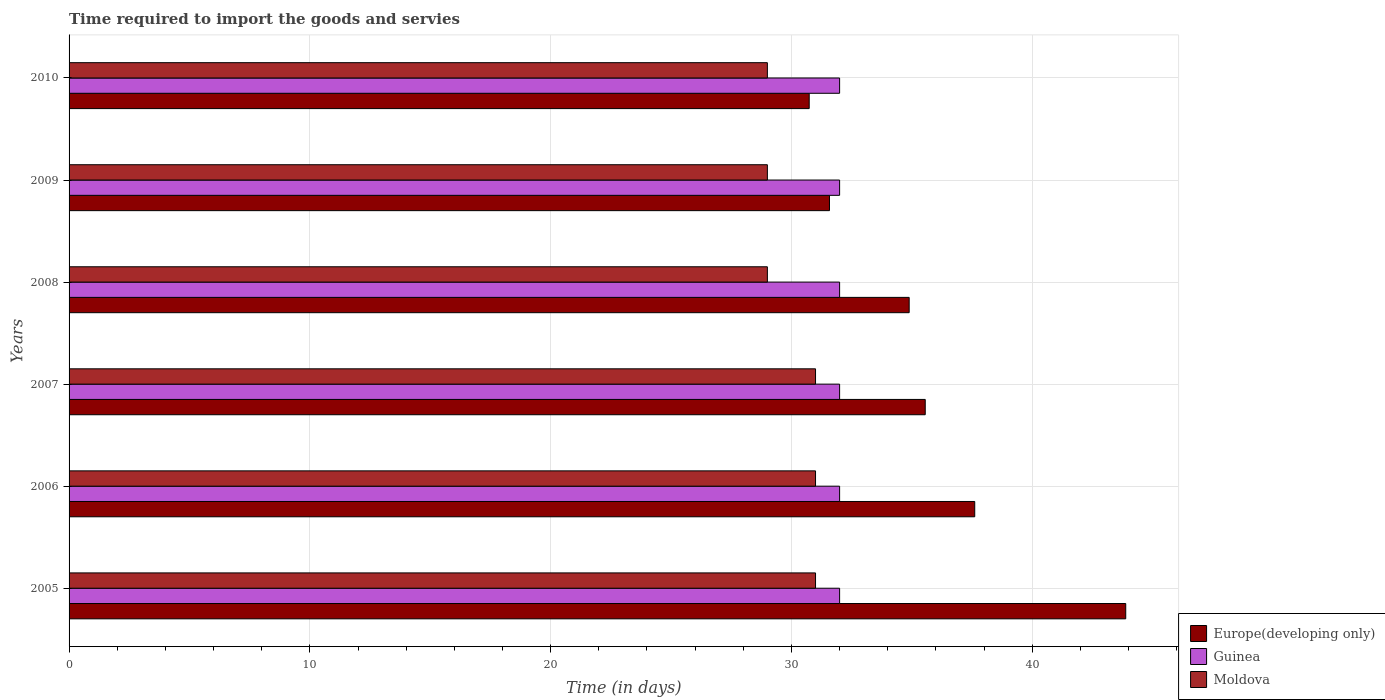How many groups of bars are there?
Make the answer very short. 6. Are the number of bars on each tick of the Y-axis equal?
Ensure brevity in your answer.  Yes. How many bars are there on the 2nd tick from the top?
Provide a short and direct response. 3. How many bars are there on the 3rd tick from the bottom?
Your answer should be very brief. 3. In how many cases, is the number of bars for a given year not equal to the number of legend labels?
Your answer should be compact. 0. What is the number of days required to import the goods and services in Europe(developing only) in 2006?
Offer a terse response. 37.61. Across all years, what is the maximum number of days required to import the goods and services in Guinea?
Keep it short and to the point. 32. Across all years, what is the minimum number of days required to import the goods and services in Europe(developing only)?
Make the answer very short. 30.74. In which year was the number of days required to import the goods and services in Europe(developing only) maximum?
Your answer should be very brief. 2005. In which year was the number of days required to import the goods and services in Europe(developing only) minimum?
Your response must be concise. 2010. What is the total number of days required to import the goods and services in Europe(developing only) in the graph?
Your answer should be very brief. 214.25. What is the difference between the number of days required to import the goods and services in Europe(developing only) in 2005 and that in 2007?
Your response must be concise. 8.33. What is the difference between the number of days required to import the goods and services in Europe(developing only) in 2010 and the number of days required to import the goods and services in Moldova in 2008?
Ensure brevity in your answer.  1.74. In the year 2008, what is the difference between the number of days required to import the goods and services in Europe(developing only) and number of days required to import the goods and services in Moldova?
Make the answer very short. 5.89. What is the ratio of the number of days required to import the goods and services in Europe(developing only) in 2005 to that in 2006?
Provide a succinct answer. 1.17. Is the number of days required to import the goods and services in Guinea in 2007 less than that in 2010?
Your response must be concise. No. What is the difference between the highest and the second highest number of days required to import the goods and services in Guinea?
Make the answer very short. 0. What is the difference between the highest and the lowest number of days required to import the goods and services in Moldova?
Offer a very short reply. 2. What does the 2nd bar from the top in 2009 represents?
Keep it short and to the point. Guinea. What does the 1st bar from the bottom in 2009 represents?
Provide a succinct answer. Europe(developing only). Is it the case that in every year, the sum of the number of days required to import the goods and services in Europe(developing only) and number of days required to import the goods and services in Moldova is greater than the number of days required to import the goods and services in Guinea?
Your response must be concise. Yes. How many years are there in the graph?
Provide a short and direct response. 6. What is the difference between two consecutive major ticks on the X-axis?
Keep it short and to the point. 10. Are the values on the major ticks of X-axis written in scientific E-notation?
Provide a short and direct response. No. Does the graph contain grids?
Provide a short and direct response. Yes. How many legend labels are there?
Your answer should be compact. 3. How are the legend labels stacked?
Provide a succinct answer. Vertical. What is the title of the graph?
Ensure brevity in your answer.  Time required to import the goods and servies. What is the label or title of the X-axis?
Provide a short and direct response. Time (in days). What is the Time (in days) in Europe(developing only) in 2005?
Provide a succinct answer. 43.88. What is the Time (in days) of Moldova in 2005?
Keep it short and to the point. 31. What is the Time (in days) in Europe(developing only) in 2006?
Ensure brevity in your answer.  37.61. What is the Time (in days) in Guinea in 2006?
Your answer should be compact. 32. What is the Time (in days) of Moldova in 2006?
Your answer should be very brief. 31. What is the Time (in days) of Europe(developing only) in 2007?
Offer a very short reply. 35.56. What is the Time (in days) in Guinea in 2007?
Your answer should be very brief. 32. What is the Time (in days) of Moldova in 2007?
Your response must be concise. 31. What is the Time (in days) of Europe(developing only) in 2008?
Your response must be concise. 34.89. What is the Time (in days) in Guinea in 2008?
Offer a very short reply. 32. What is the Time (in days) of Moldova in 2008?
Give a very brief answer. 29. What is the Time (in days) in Europe(developing only) in 2009?
Provide a short and direct response. 31.58. What is the Time (in days) in Guinea in 2009?
Ensure brevity in your answer.  32. What is the Time (in days) in Moldova in 2009?
Provide a short and direct response. 29. What is the Time (in days) in Europe(developing only) in 2010?
Make the answer very short. 30.74. Across all years, what is the maximum Time (in days) of Europe(developing only)?
Keep it short and to the point. 43.88. Across all years, what is the maximum Time (in days) of Guinea?
Offer a very short reply. 32. Across all years, what is the maximum Time (in days) in Moldova?
Provide a succinct answer. 31. Across all years, what is the minimum Time (in days) in Europe(developing only)?
Your response must be concise. 30.74. Across all years, what is the minimum Time (in days) of Guinea?
Your answer should be compact. 32. Across all years, what is the minimum Time (in days) in Moldova?
Provide a succinct answer. 29. What is the total Time (in days) in Europe(developing only) in the graph?
Make the answer very short. 214.25. What is the total Time (in days) of Guinea in the graph?
Your answer should be compact. 192. What is the total Time (in days) in Moldova in the graph?
Your response must be concise. 180. What is the difference between the Time (in days) of Europe(developing only) in 2005 and that in 2006?
Keep it short and to the point. 6.27. What is the difference between the Time (in days) in Europe(developing only) in 2005 and that in 2007?
Keep it short and to the point. 8.33. What is the difference between the Time (in days) of Guinea in 2005 and that in 2007?
Give a very brief answer. 0. What is the difference between the Time (in days) of Europe(developing only) in 2005 and that in 2008?
Give a very brief answer. 8.99. What is the difference between the Time (in days) in Guinea in 2005 and that in 2008?
Offer a terse response. 0. What is the difference between the Time (in days) in Europe(developing only) in 2005 and that in 2009?
Your response must be concise. 12.3. What is the difference between the Time (in days) in Guinea in 2005 and that in 2009?
Offer a very short reply. 0. What is the difference between the Time (in days) in Moldova in 2005 and that in 2009?
Provide a succinct answer. 2. What is the difference between the Time (in days) of Europe(developing only) in 2005 and that in 2010?
Make the answer very short. 13.15. What is the difference between the Time (in days) in Europe(developing only) in 2006 and that in 2007?
Offer a very short reply. 2.06. What is the difference between the Time (in days) of Guinea in 2006 and that in 2007?
Make the answer very short. 0. What is the difference between the Time (in days) of Moldova in 2006 and that in 2007?
Offer a very short reply. 0. What is the difference between the Time (in days) of Europe(developing only) in 2006 and that in 2008?
Your answer should be very brief. 2.72. What is the difference between the Time (in days) of Guinea in 2006 and that in 2008?
Offer a terse response. 0. What is the difference between the Time (in days) of Moldova in 2006 and that in 2008?
Provide a short and direct response. 2. What is the difference between the Time (in days) of Europe(developing only) in 2006 and that in 2009?
Your answer should be very brief. 6.03. What is the difference between the Time (in days) of Guinea in 2006 and that in 2009?
Your response must be concise. 0. What is the difference between the Time (in days) in Europe(developing only) in 2006 and that in 2010?
Offer a terse response. 6.87. What is the difference between the Time (in days) in Moldova in 2007 and that in 2008?
Offer a very short reply. 2. What is the difference between the Time (in days) in Europe(developing only) in 2007 and that in 2009?
Offer a very short reply. 3.98. What is the difference between the Time (in days) in Europe(developing only) in 2007 and that in 2010?
Make the answer very short. 4.82. What is the difference between the Time (in days) of Guinea in 2007 and that in 2010?
Provide a short and direct response. 0. What is the difference between the Time (in days) in Moldova in 2007 and that in 2010?
Your response must be concise. 2. What is the difference between the Time (in days) in Europe(developing only) in 2008 and that in 2009?
Your response must be concise. 3.31. What is the difference between the Time (in days) of Guinea in 2008 and that in 2009?
Give a very brief answer. 0. What is the difference between the Time (in days) of Moldova in 2008 and that in 2009?
Make the answer very short. 0. What is the difference between the Time (in days) in Europe(developing only) in 2008 and that in 2010?
Offer a terse response. 4.15. What is the difference between the Time (in days) in Guinea in 2008 and that in 2010?
Offer a terse response. 0. What is the difference between the Time (in days) in Moldova in 2008 and that in 2010?
Keep it short and to the point. 0. What is the difference between the Time (in days) in Europe(developing only) in 2009 and that in 2010?
Ensure brevity in your answer.  0.84. What is the difference between the Time (in days) in Guinea in 2009 and that in 2010?
Ensure brevity in your answer.  0. What is the difference between the Time (in days) of Europe(developing only) in 2005 and the Time (in days) of Guinea in 2006?
Ensure brevity in your answer.  11.88. What is the difference between the Time (in days) of Europe(developing only) in 2005 and the Time (in days) of Moldova in 2006?
Your response must be concise. 12.88. What is the difference between the Time (in days) of Europe(developing only) in 2005 and the Time (in days) of Guinea in 2007?
Offer a very short reply. 11.88. What is the difference between the Time (in days) in Europe(developing only) in 2005 and the Time (in days) in Moldova in 2007?
Your answer should be compact. 12.88. What is the difference between the Time (in days) of Europe(developing only) in 2005 and the Time (in days) of Guinea in 2008?
Provide a succinct answer. 11.88. What is the difference between the Time (in days) of Europe(developing only) in 2005 and the Time (in days) of Moldova in 2008?
Give a very brief answer. 14.88. What is the difference between the Time (in days) of Guinea in 2005 and the Time (in days) of Moldova in 2008?
Your answer should be very brief. 3. What is the difference between the Time (in days) of Europe(developing only) in 2005 and the Time (in days) of Guinea in 2009?
Your response must be concise. 11.88. What is the difference between the Time (in days) in Europe(developing only) in 2005 and the Time (in days) in Moldova in 2009?
Provide a short and direct response. 14.88. What is the difference between the Time (in days) of Guinea in 2005 and the Time (in days) of Moldova in 2009?
Offer a very short reply. 3. What is the difference between the Time (in days) of Europe(developing only) in 2005 and the Time (in days) of Guinea in 2010?
Ensure brevity in your answer.  11.88. What is the difference between the Time (in days) of Europe(developing only) in 2005 and the Time (in days) of Moldova in 2010?
Make the answer very short. 14.88. What is the difference between the Time (in days) in Guinea in 2005 and the Time (in days) in Moldova in 2010?
Your response must be concise. 3. What is the difference between the Time (in days) in Europe(developing only) in 2006 and the Time (in days) in Guinea in 2007?
Your answer should be compact. 5.61. What is the difference between the Time (in days) of Europe(developing only) in 2006 and the Time (in days) of Moldova in 2007?
Your answer should be very brief. 6.61. What is the difference between the Time (in days) in Europe(developing only) in 2006 and the Time (in days) in Guinea in 2008?
Offer a very short reply. 5.61. What is the difference between the Time (in days) of Europe(developing only) in 2006 and the Time (in days) of Moldova in 2008?
Your response must be concise. 8.61. What is the difference between the Time (in days) of Guinea in 2006 and the Time (in days) of Moldova in 2008?
Your response must be concise. 3. What is the difference between the Time (in days) in Europe(developing only) in 2006 and the Time (in days) in Guinea in 2009?
Offer a terse response. 5.61. What is the difference between the Time (in days) of Europe(developing only) in 2006 and the Time (in days) of Moldova in 2009?
Keep it short and to the point. 8.61. What is the difference between the Time (in days) in Guinea in 2006 and the Time (in days) in Moldova in 2009?
Make the answer very short. 3. What is the difference between the Time (in days) of Europe(developing only) in 2006 and the Time (in days) of Guinea in 2010?
Make the answer very short. 5.61. What is the difference between the Time (in days) in Europe(developing only) in 2006 and the Time (in days) in Moldova in 2010?
Provide a short and direct response. 8.61. What is the difference between the Time (in days) in Guinea in 2006 and the Time (in days) in Moldova in 2010?
Your response must be concise. 3. What is the difference between the Time (in days) of Europe(developing only) in 2007 and the Time (in days) of Guinea in 2008?
Your answer should be very brief. 3.56. What is the difference between the Time (in days) of Europe(developing only) in 2007 and the Time (in days) of Moldova in 2008?
Your response must be concise. 6.56. What is the difference between the Time (in days) in Guinea in 2007 and the Time (in days) in Moldova in 2008?
Offer a terse response. 3. What is the difference between the Time (in days) of Europe(developing only) in 2007 and the Time (in days) of Guinea in 2009?
Provide a short and direct response. 3.56. What is the difference between the Time (in days) of Europe(developing only) in 2007 and the Time (in days) of Moldova in 2009?
Offer a terse response. 6.56. What is the difference between the Time (in days) in Guinea in 2007 and the Time (in days) in Moldova in 2009?
Offer a very short reply. 3. What is the difference between the Time (in days) of Europe(developing only) in 2007 and the Time (in days) of Guinea in 2010?
Offer a terse response. 3.56. What is the difference between the Time (in days) in Europe(developing only) in 2007 and the Time (in days) in Moldova in 2010?
Keep it short and to the point. 6.56. What is the difference between the Time (in days) of Europe(developing only) in 2008 and the Time (in days) of Guinea in 2009?
Your response must be concise. 2.89. What is the difference between the Time (in days) in Europe(developing only) in 2008 and the Time (in days) in Moldova in 2009?
Offer a terse response. 5.89. What is the difference between the Time (in days) in Guinea in 2008 and the Time (in days) in Moldova in 2009?
Provide a succinct answer. 3. What is the difference between the Time (in days) of Europe(developing only) in 2008 and the Time (in days) of Guinea in 2010?
Keep it short and to the point. 2.89. What is the difference between the Time (in days) of Europe(developing only) in 2008 and the Time (in days) of Moldova in 2010?
Give a very brief answer. 5.89. What is the difference between the Time (in days) of Guinea in 2008 and the Time (in days) of Moldova in 2010?
Provide a short and direct response. 3. What is the difference between the Time (in days) of Europe(developing only) in 2009 and the Time (in days) of Guinea in 2010?
Your answer should be very brief. -0.42. What is the difference between the Time (in days) in Europe(developing only) in 2009 and the Time (in days) in Moldova in 2010?
Your answer should be compact. 2.58. What is the average Time (in days) of Europe(developing only) per year?
Keep it short and to the point. 35.71. What is the average Time (in days) of Guinea per year?
Give a very brief answer. 32. In the year 2005, what is the difference between the Time (in days) in Europe(developing only) and Time (in days) in Guinea?
Make the answer very short. 11.88. In the year 2005, what is the difference between the Time (in days) of Europe(developing only) and Time (in days) of Moldova?
Provide a short and direct response. 12.88. In the year 2005, what is the difference between the Time (in days) of Guinea and Time (in days) of Moldova?
Keep it short and to the point. 1. In the year 2006, what is the difference between the Time (in days) of Europe(developing only) and Time (in days) of Guinea?
Give a very brief answer. 5.61. In the year 2006, what is the difference between the Time (in days) in Europe(developing only) and Time (in days) in Moldova?
Keep it short and to the point. 6.61. In the year 2007, what is the difference between the Time (in days) in Europe(developing only) and Time (in days) in Guinea?
Make the answer very short. 3.56. In the year 2007, what is the difference between the Time (in days) in Europe(developing only) and Time (in days) in Moldova?
Your answer should be compact. 4.56. In the year 2007, what is the difference between the Time (in days) of Guinea and Time (in days) of Moldova?
Keep it short and to the point. 1. In the year 2008, what is the difference between the Time (in days) of Europe(developing only) and Time (in days) of Guinea?
Offer a very short reply. 2.89. In the year 2008, what is the difference between the Time (in days) of Europe(developing only) and Time (in days) of Moldova?
Ensure brevity in your answer.  5.89. In the year 2009, what is the difference between the Time (in days) in Europe(developing only) and Time (in days) in Guinea?
Keep it short and to the point. -0.42. In the year 2009, what is the difference between the Time (in days) of Europe(developing only) and Time (in days) of Moldova?
Offer a terse response. 2.58. In the year 2010, what is the difference between the Time (in days) of Europe(developing only) and Time (in days) of Guinea?
Give a very brief answer. -1.26. In the year 2010, what is the difference between the Time (in days) in Europe(developing only) and Time (in days) in Moldova?
Provide a short and direct response. 1.74. What is the ratio of the Time (in days) in Guinea in 2005 to that in 2006?
Offer a terse response. 1. What is the ratio of the Time (in days) of Moldova in 2005 to that in 2006?
Offer a terse response. 1. What is the ratio of the Time (in days) of Europe(developing only) in 2005 to that in 2007?
Provide a short and direct response. 1.23. What is the ratio of the Time (in days) in Guinea in 2005 to that in 2007?
Offer a terse response. 1. What is the ratio of the Time (in days) in Europe(developing only) in 2005 to that in 2008?
Keep it short and to the point. 1.26. What is the ratio of the Time (in days) in Guinea in 2005 to that in 2008?
Offer a terse response. 1. What is the ratio of the Time (in days) in Moldova in 2005 to that in 2008?
Provide a succinct answer. 1.07. What is the ratio of the Time (in days) in Europe(developing only) in 2005 to that in 2009?
Offer a terse response. 1.39. What is the ratio of the Time (in days) in Moldova in 2005 to that in 2009?
Give a very brief answer. 1.07. What is the ratio of the Time (in days) of Europe(developing only) in 2005 to that in 2010?
Give a very brief answer. 1.43. What is the ratio of the Time (in days) in Guinea in 2005 to that in 2010?
Ensure brevity in your answer.  1. What is the ratio of the Time (in days) of Moldova in 2005 to that in 2010?
Your answer should be compact. 1.07. What is the ratio of the Time (in days) in Europe(developing only) in 2006 to that in 2007?
Your response must be concise. 1.06. What is the ratio of the Time (in days) of Guinea in 2006 to that in 2007?
Offer a very short reply. 1. What is the ratio of the Time (in days) in Moldova in 2006 to that in 2007?
Your answer should be compact. 1. What is the ratio of the Time (in days) of Europe(developing only) in 2006 to that in 2008?
Keep it short and to the point. 1.08. What is the ratio of the Time (in days) in Moldova in 2006 to that in 2008?
Provide a short and direct response. 1.07. What is the ratio of the Time (in days) of Europe(developing only) in 2006 to that in 2009?
Ensure brevity in your answer.  1.19. What is the ratio of the Time (in days) in Moldova in 2006 to that in 2009?
Your answer should be very brief. 1.07. What is the ratio of the Time (in days) in Europe(developing only) in 2006 to that in 2010?
Provide a succinct answer. 1.22. What is the ratio of the Time (in days) in Moldova in 2006 to that in 2010?
Provide a short and direct response. 1.07. What is the ratio of the Time (in days) of Europe(developing only) in 2007 to that in 2008?
Offer a very short reply. 1.02. What is the ratio of the Time (in days) in Moldova in 2007 to that in 2008?
Offer a very short reply. 1.07. What is the ratio of the Time (in days) in Europe(developing only) in 2007 to that in 2009?
Make the answer very short. 1.13. What is the ratio of the Time (in days) of Moldova in 2007 to that in 2009?
Give a very brief answer. 1.07. What is the ratio of the Time (in days) in Europe(developing only) in 2007 to that in 2010?
Your answer should be compact. 1.16. What is the ratio of the Time (in days) of Guinea in 2007 to that in 2010?
Give a very brief answer. 1. What is the ratio of the Time (in days) of Moldova in 2007 to that in 2010?
Your response must be concise. 1.07. What is the ratio of the Time (in days) of Europe(developing only) in 2008 to that in 2009?
Offer a terse response. 1.1. What is the ratio of the Time (in days) in Guinea in 2008 to that in 2009?
Ensure brevity in your answer.  1. What is the ratio of the Time (in days) in Moldova in 2008 to that in 2009?
Ensure brevity in your answer.  1. What is the ratio of the Time (in days) of Europe(developing only) in 2008 to that in 2010?
Make the answer very short. 1.14. What is the ratio of the Time (in days) in Guinea in 2008 to that in 2010?
Offer a very short reply. 1. What is the ratio of the Time (in days) of Moldova in 2008 to that in 2010?
Your response must be concise. 1. What is the ratio of the Time (in days) of Europe(developing only) in 2009 to that in 2010?
Provide a short and direct response. 1.03. What is the ratio of the Time (in days) in Guinea in 2009 to that in 2010?
Make the answer very short. 1. What is the difference between the highest and the second highest Time (in days) of Europe(developing only)?
Your answer should be very brief. 6.27. What is the difference between the highest and the lowest Time (in days) of Europe(developing only)?
Give a very brief answer. 13.15. 